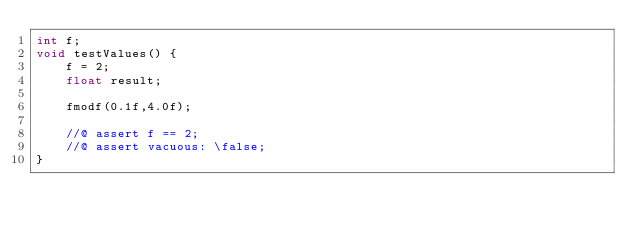Convert code to text. <code><loc_0><loc_0><loc_500><loc_500><_C_>int f;
void testValues() {
    f = 2;
    float result;
    
    fmodf(0.1f,4.0f);
    
    //@ assert f == 2;
    //@ assert vacuous: \false;
}
</code> 